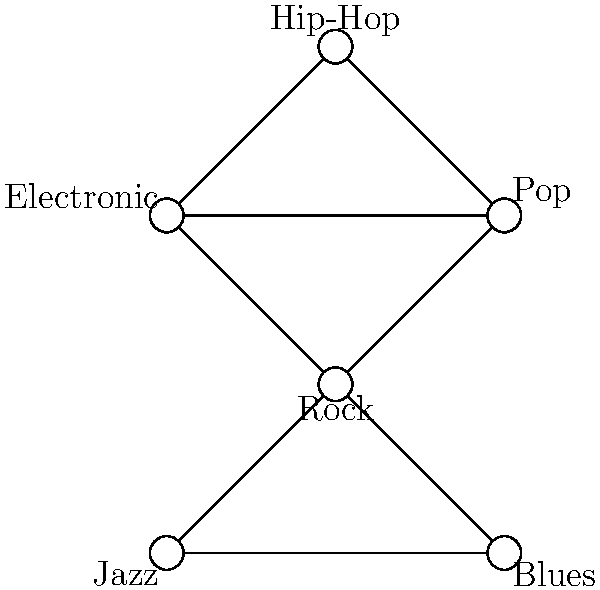In the given graph representation of musical genres and their relationships, which genre has the highest out-degree, and what does this suggest about its influence on other genres? To answer this question, we need to follow these steps:

1. Understand the concept of out-degree in graph theory:
   - Out-degree is the number of edges pointing away from a vertex.

2. Analyze each genre (vertex) in the graph:
   - Rock: 3 outgoing edges (to Pop, Electronic, Jazz, and Blues)
   - Pop: 1 outgoing edge (to Hip-Hop)
   - Electronic: 1 outgoing edge (to Hip-Hop)
   - Jazz: 1 outgoing edge (to Blues)
   - Blues: 1 outgoing edge (to Rock)
   - Hip-Hop: 0 outgoing edges

3. Identify the genre with the highest out-degree:
   - Rock has the highest out-degree with 3 outgoing edges.

4. Interpret the meaning of high out-degree in this context:
   - A high out-degree suggests that the genre has a strong influence on other genres.
   - It implies that Rock has contributed elements or characteristics to multiple other genres.

5. Consider the implications for music history and development:
   - This representation suggests that Rock has been a significant influencer in the evolution of various musical styles.
   - It aligns with the historical impact of Rock music on the development of Pop, Electronic music, and its roots in Jazz and Blues.
Answer: Rock; it suggests strong influence on multiple genres. 